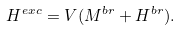<formula> <loc_0><loc_0><loc_500><loc_500>H ^ { e x c } = V ( M ^ { b r } + H ^ { b r } ) .</formula> 